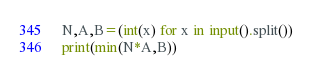<code> <loc_0><loc_0><loc_500><loc_500><_Python_>N,A,B=(int(x) for x in input().split())
print(min(N*A,B))
</code> 